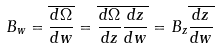<formula> <loc_0><loc_0><loc_500><loc_500>B _ { w } = \overline { \frac { d \Omega } { d w } } = \overline { \frac { d \Omega } { d z } \frac { d z } { d w } } = B _ { z } \overline { \frac { d z } { d w } }</formula> 